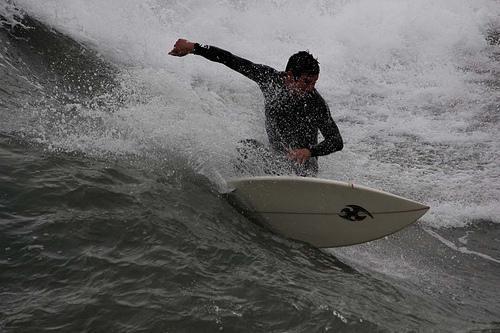How many people are surfing?
Give a very brief answer. 1. 